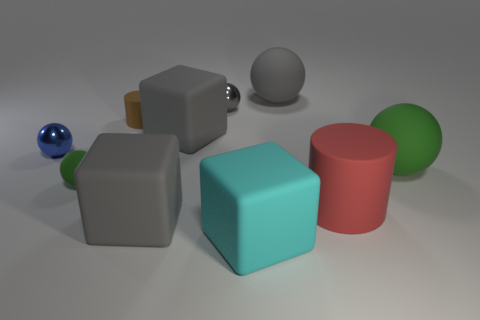There is a green thing that is on the right side of the matte cylinder in front of the small blue shiny thing; how many tiny matte things are in front of it?
Give a very brief answer. 1. There is another small object that is the same material as the small blue thing; what color is it?
Provide a short and direct response. Gray. Is the size of the rubber thing behind the brown cylinder the same as the big green object?
Provide a short and direct response. Yes. What number of objects are blue metal objects or brown cylinders?
Your answer should be very brief. 2. What material is the tiny sphere that is right of the big gray block in front of the green rubber thing to the right of the large cyan object?
Offer a terse response. Metal. What material is the small sphere that is behind the small blue metallic thing?
Your answer should be compact. Metal. Is there a object of the same size as the gray metallic ball?
Your response must be concise. Yes. There is a matte thing that is to the right of the red matte object; does it have the same color as the small rubber sphere?
Your response must be concise. Yes. How many yellow things are either tiny metal things or big matte cylinders?
Keep it short and to the point. 0. How many rubber things have the same color as the large cylinder?
Offer a very short reply. 0. 